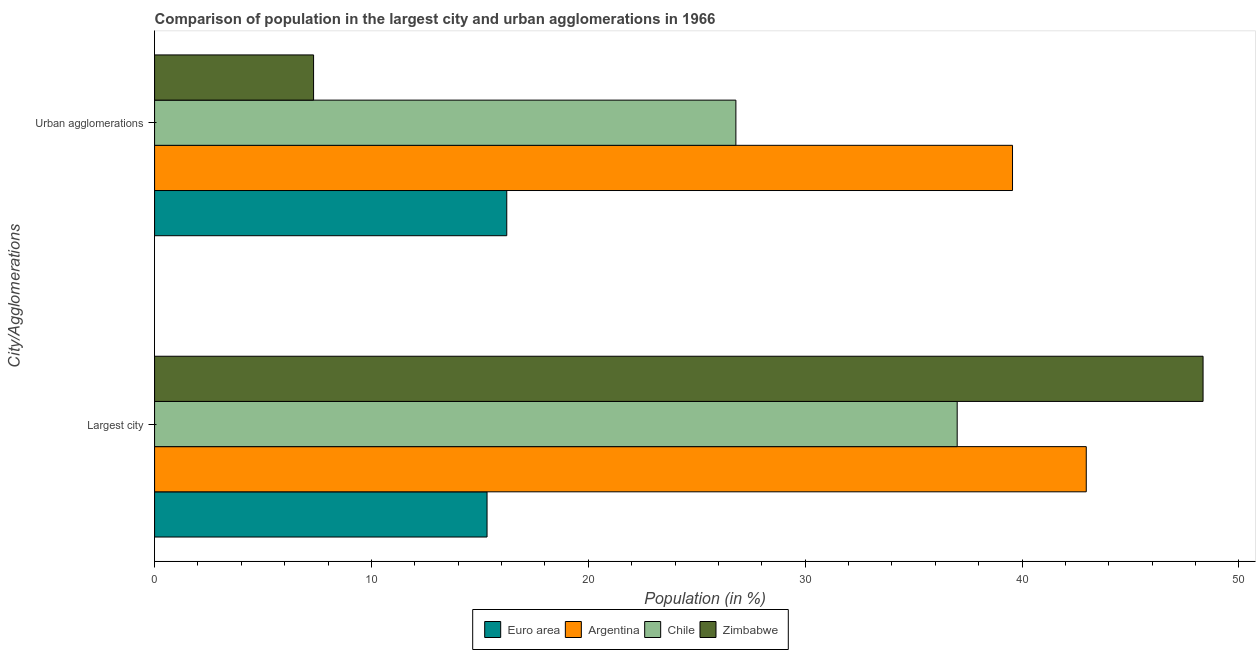How many different coloured bars are there?
Your answer should be very brief. 4. Are the number of bars on each tick of the Y-axis equal?
Keep it short and to the point. Yes. How many bars are there on the 2nd tick from the bottom?
Your answer should be very brief. 4. What is the label of the 2nd group of bars from the top?
Your answer should be compact. Largest city. What is the population in urban agglomerations in Argentina?
Provide a succinct answer. 39.56. Across all countries, what is the maximum population in the largest city?
Provide a short and direct response. 48.35. Across all countries, what is the minimum population in the largest city?
Your answer should be very brief. 15.33. In which country was the population in urban agglomerations minimum?
Provide a succinct answer. Zimbabwe. What is the total population in urban agglomerations in the graph?
Your answer should be very brief. 89.94. What is the difference between the population in the largest city in Zimbabwe and that in Chile?
Your response must be concise. 11.34. What is the difference between the population in the largest city in Euro area and the population in urban agglomerations in Zimbabwe?
Ensure brevity in your answer.  8. What is the average population in urban agglomerations per country?
Offer a terse response. 22.48. What is the difference between the population in urban agglomerations and population in the largest city in Euro area?
Make the answer very short. 0.91. What is the ratio of the population in the largest city in Euro area to that in Chile?
Your answer should be very brief. 0.41. Is the population in urban agglomerations in Euro area less than that in Chile?
Provide a short and direct response. Yes. Are all the bars in the graph horizontal?
Your answer should be very brief. Yes. What is the difference between two consecutive major ticks on the X-axis?
Provide a short and direct response. 10. Does the graph contain grids?
Your answer should be very brief. No. Where does the legend appear in the graph?
Make the answer very short. Bottom center. How many legend labels are there?
Your response must be concise. 4. What is the title of the graph?
Offer a terse response. Comparison of population in the largest city and urban agglomerations in 1966. Does "Antigua and Barbuda" appear as one of the legend labels in the graph?
Your answer should be compact. No. What is the label or title of the X-axis?
Keep it short and to the point. Population (in %). What is the label or title of the Y-axis?
Your answer should be compact. City/Agglomerations. What is the Population (in %) in Euro area in Largest city?
Your answer should be compact. 15.33. What is the Population (in %) of Argentina in Largest city?
Provide a short and direct response. 42.96. What is the Population (in %) of Chile in Largest city?
Your answer should be very brief. 37.01. What is the Population (in %) of Zimbabwe in Largest city?
Keep it short and to the point. 48.35. What is the Population (in %) in Euro area in Urban agglomerations?
Give a very brief answer. 16.24. What is the Population (in %) in Argentina in Urban agglomerations?
Your response must be concise. 39.56. What is the Population (in %) in Chile in Urban agglomerations?
Offer a very short reply. 26.81. What is the Population (in %) in Zimbabwe in Urban agglomerations?
Your answer should be compact. 7.33. Across all City/Agglomerations, what is the maximum Population (in %) in Euro area?
Keep it short and to the point. 16.24. Across all City/Agglomerations, what is the maximum Population (in %) of Argentina?
Your response must be concise. 42.96. Across all City/Agglomerations, what is the maximum Population (in %) of Chile?
Offer a very short reply. 37.01. Across all City/Agglomerations, what is the maximum Population (in %) of Zimbabwe?
Ensure brevity in your answer.  48.35. Across all City/Agglomerations, what is the minimum Population (in %) in Euro area?
Keep it short and to the point. 15.33. Across all City/Agglomerations, what is the minimum Population (in %) in Argentina?
Give a very brief answer. 39.56. Across all City/Agglomerations, what is the minimum Population (in %) in Chile?
Offer a very short reply. 26.81. Across all City/Agglomerations, what is the minimum Population (in %) of Zimbabwe?
Provide a succinct answer. 7.33. What is the total Population (in %) of Euro area in the graph?
Your answer should be very brief. 31.57. What is the total Population (in %) in Argentina in the graph?
Your response must be concise. 82.52. What is the total Population (in %) in Chile in the graph?
Provide a short and direct response. 63.82. What is the total Population (in %) in Zimbabwe in the graph?
Ensure brevity in your answer.  55.68. What is the difference between the Population (in %) of Euro area in Largest city and that in Urban agglomerations?
Keep it short and to the point. -0.91. What is the difference between the Population (in %) of Argentina in Largest city and that in Urban agglomerations?
Provide a short and direct response. 3.4. What is the difference between the Population (in %) in Chile in Largest city and that in Urban agglomerations?
Provide a succinct answer. 10.2. What is the difference between the Population (in %) of Zimbabwe in Largest city and that in Urban agglomerations?
Ensure brevity in your answer.  41.02. What is the difference between the Population (in %) in Euro area in Largest city and the Population (in %) in Argentina in Urban agglomerations?
Offer a very short reply. -24.23. What is the difference between the Population (in %) of Euro area in Largest city and the Population (in %) of Chile in Urban agglomerations?
Ensure brevity in your answer.  -11.47. What is the difference between the Population (in %) in Euro area in Largest city and the Population (in %) in Zimbabwe in Urban agglomerations?
Offer a terse response. 8. What is the difference between the Population (in %) in Argentina in Largest city and the Population (in %) in Chile in Urban agglomerations?
Give a very brief answer. 16.16. What is the difference between the Population (in %) of Argentina in Largest city and the Population (in %) of Zimbabwe in Urban agglomerations?
Make the answer very short. 35.63. What is the difference between the Population (in %) in Chile in Largest city and the Population (in %) in Zimbabwe in Urban agglomerations?
Keep it short and to the point. 29.68. What is the average Population (in %) of Euro area per City/Agglomerations?
Offer a very short reply. 15.79. What is the average Population (in %) of Argentina per City/Agglomerations?
Offer a terse response. 41.26. What is the average Population (in %) of Chile per City/Agglomerations?
Give a very brief answer. 31.91. What is the average Population (in %) in Zimbabwe per City/Agglomerations?
Your answer should be very brief. 27.84. What is the difference between the Population (in %) of Euro area and Population (in %) of Argentina in Largest city?
Offer a very short reply. -27.63. What is the difference between the Population (in %) in Euro area and Population (in %) in Chile in Largest city?
Your answer should be compact. -21.68. What is the difference between the Population (in %) in Euro area and Population (in %) in Zimbabwe in Largest city?
Your answer should be very brief. -33.02. What is the difference between the Population (in %) of Argentina and Population (in %) of Chile in Largest city?
Your answer should be compact. 5.95. What is the difference between the Population (in %) in Argentina and Population (in %) in Zimbabwe in Largest city?
Ensure brevity in your answer.  -5.39. What is the difference between the Population (in %) in Chile and Population (in %) in Zimbabwe in Largest city?
Provide a short and direct response. -11.34. What is the difference between the Population (in %) of Euro area and Population (in %) of Argentina in Urban agglomerations?
Provide a short and direct response. -23.32. What is the difference between the Population (in %) in Euro area and Population (in %) in Chile in Urban agglomerations?
Provide a short and direct response. -10.57. What is the difference between the Population (in %) of Euro area and Population (in %) of Zimbabwe in Urban agglomerations?
Keep it short and to the point. 8.91. What is the difference between the Population (in %) in Argentina and Population (in %) in Chile in Urban agglomerations?
Provide a succinct answer. 12.76. What is the difference between the Population (in %) of Argentina and Population (in %) of Zimbabwe in Urban agglomerations?
Offer a very short reply. 32.23. What is the difference between the Population (in %) in Chile and Population (in %) in Zimbabwe in Urban agglomerations?
Provide a short and direct response. 19.47. What is the ratio of the Population (in %) in Euro area in Largest city to that in Urban agglomerations?
Provide a succinct answer. 0.94. What is the ratio of the Population (in %) of Argentina in Largest city to that in Urban agglomerations?
Your answer should be compact. 1.09. What is the ratio of the Population (in %) of Chile in Largest city to that in Urban agglomerations?
Ensure brevity in your answer.  1.38. What is the ratio of the Population (in %) of Zimbabwe in Largest city to that in Urban agglomerations?
Your answer should be compact. 6.59. What is the difference between the highest and the second highest Population (in %) in Euro area?
Offer a very short reply. 0.91. What is the difference between the highest and the second highest Population (in %) in Argentina?
Make the answer very short. 3.4. What is the difference between the highest and the second highest Population (in %) in Chile?
Give a very brief answer. 10.2. What is the difference between the highest and the second highest Population (in %) of Zimbabwe?
Ensure brevity in your answer.  41.02. What is the difference between the highest and the lowest Population (in %) in Euro area?
Ensure brevity in your answer.  0.91. What is the difference between the highest and the lowest Population (in %) in Argentina?
Ensure brevity in your answer.  3.4. What is the difference between the highest and the lowest Population (in %) in Chile?
Provide a short and direct response. 10.2. What is the difference between the highest and the lowest Population (in %) of Zimbabwe?
Give a very brief answer. 41.02. 